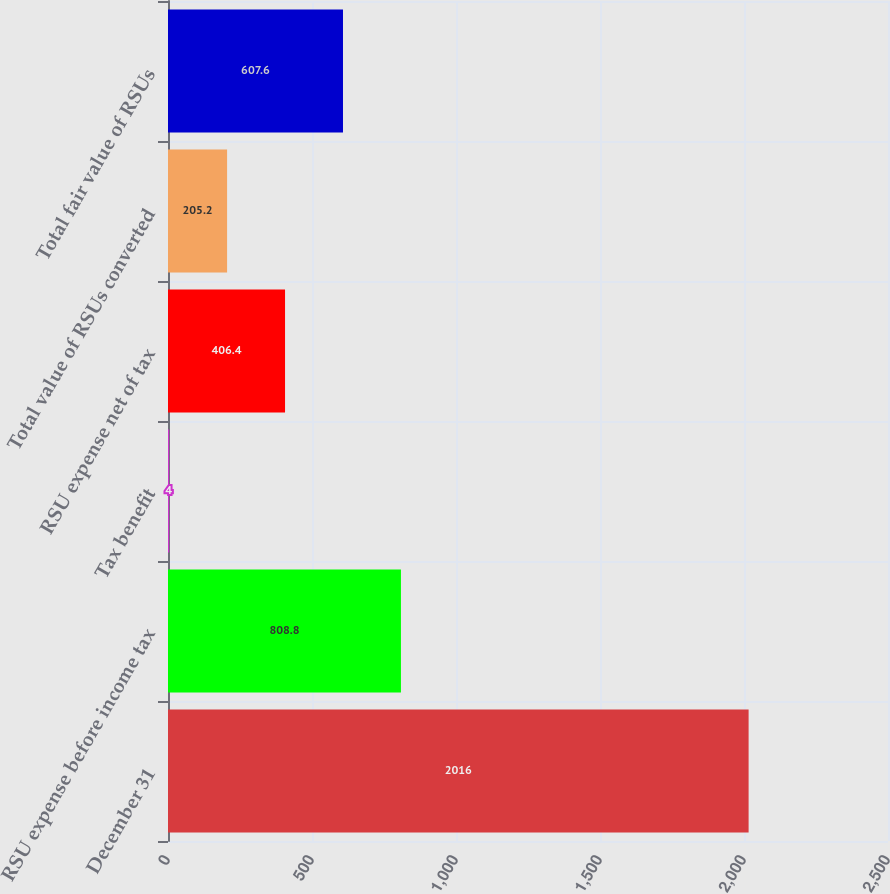Convert chart to OTSL. <chart><loc_0><loc_0><loc_500><loc_500><bar_chart><fcel>December 31<fcel>RSU expense before income tax<fcel>Tax benefit<fcel>RSU expense net of tax<fcel>Total value of RSUs converted<fcel>Total fair value of RSUs<nl><fcel>2016<fcel>808.8<fcel>4<fcel>406.4<fcel>205.2<fcel>607.6<nl></chart> 